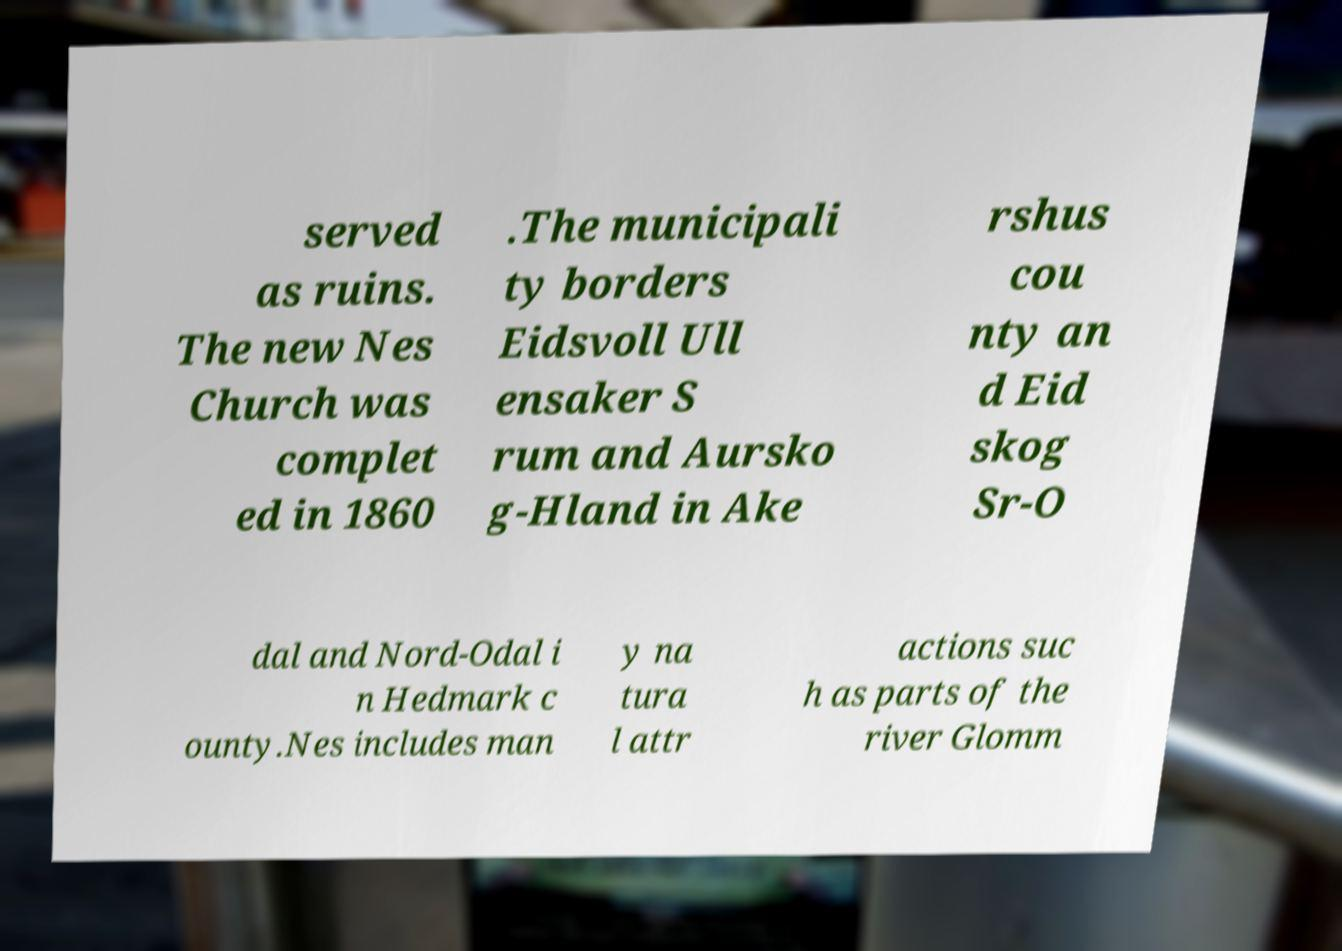Could you extract and type out the text from this image? served as ruins. The new Nes Church was complet ed in 1860 .The municipali ty borders Eidsvoll Ull ensaker S rum and Aursko g-Hland in Ake rshus cou nty an d Eid skog Sr-O dal and Nord-Odal i n Hedmark c ounty.Nes includes man y na tura l attr actions suc h as parts of the river Glomm 